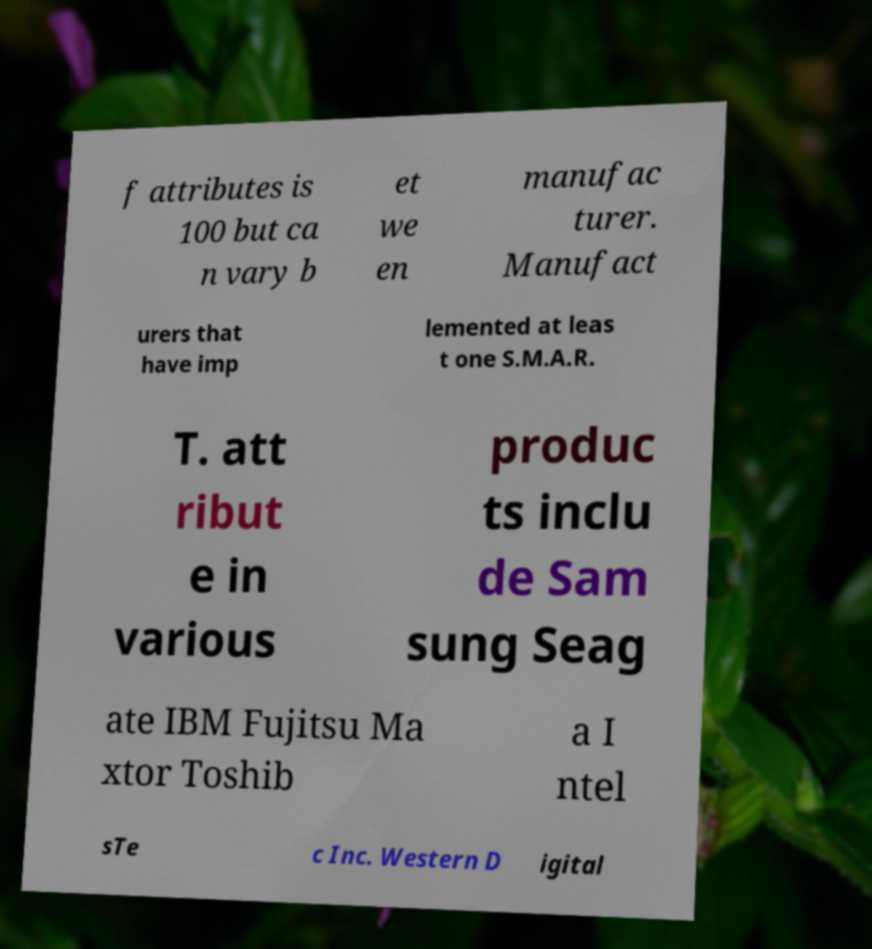What messages or text are displayed in this image? I need them in a readable, typed format. f attributes is 100 but ca n vary b et we en manufac turer. Manufact urers that have imp lemented at leas t one S.M.A.R. T. att ribut e in various produc ts inclu de Sam sung Seag ate IBM Fujitsu Ma xtor Toshib a I ntel sTe c Inc. Western D igital 